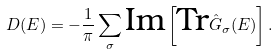Convert formula to latex. <formula><loc_0><loc_0><loc_500><loc_500>D ( E ) = - \frac { 1 } { \pi } \sum _ { \sigma } \text {Im} \left [ \text {Tr} \hat { G } _ { \sigma } ( E ) \right ] .</formula> 